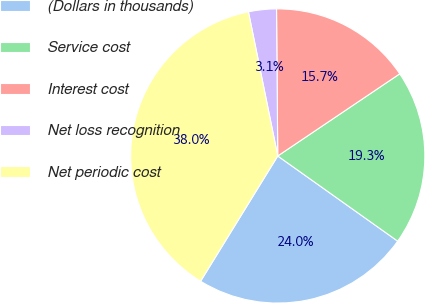Convert chart. <chart><loc_0><loc_0><loc_500><loc_500><pie_chart><fcel>(Dollars in thousands)<fcel>Service cost<fcel>Interest cost<fcel>Net loss recognition<fcel>Net periodic cost<nl><fcel>23.96%<fcel>19.26%<fcel>15.7%<fcel>3.06%<fcel>38.02%<nl></chart> 